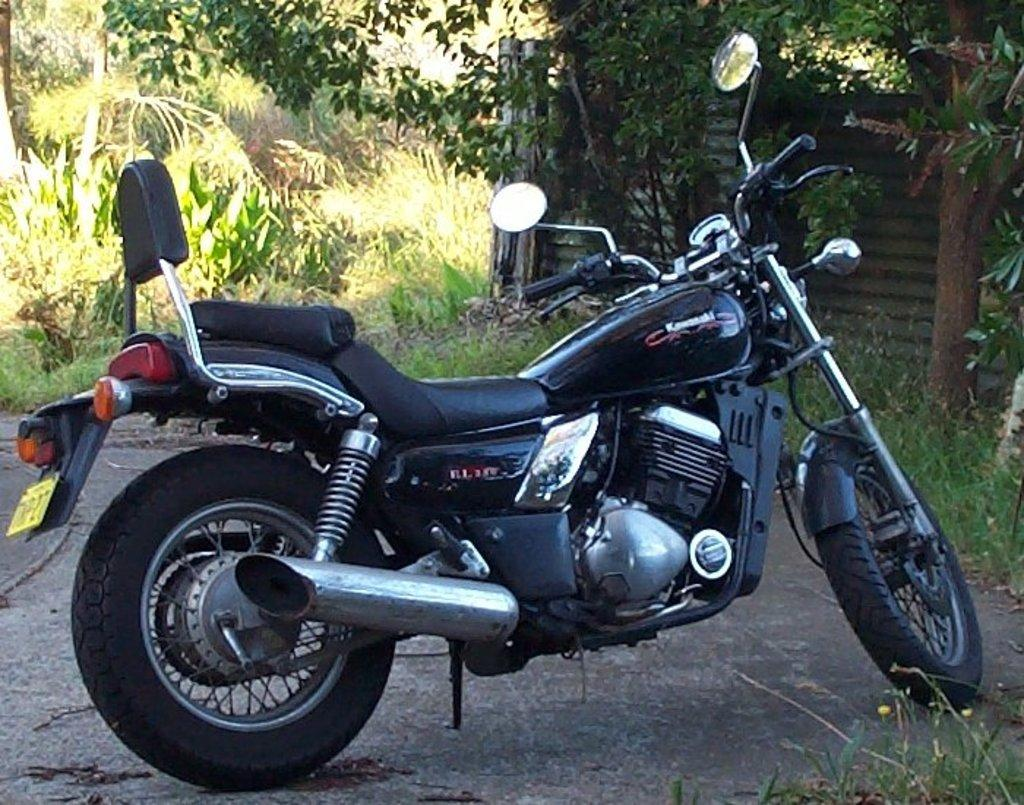What object is on the ground in the image? There is a bike on the ground in the image. What can be seen in the background of the image? There is a wall, trees, and plants visible in the background of the image. What type of fish can be seen swimming in the snow in the image? There is no fish or snow present in the image; it features a bike on the ground and a background with a wall, trees, and plants. 